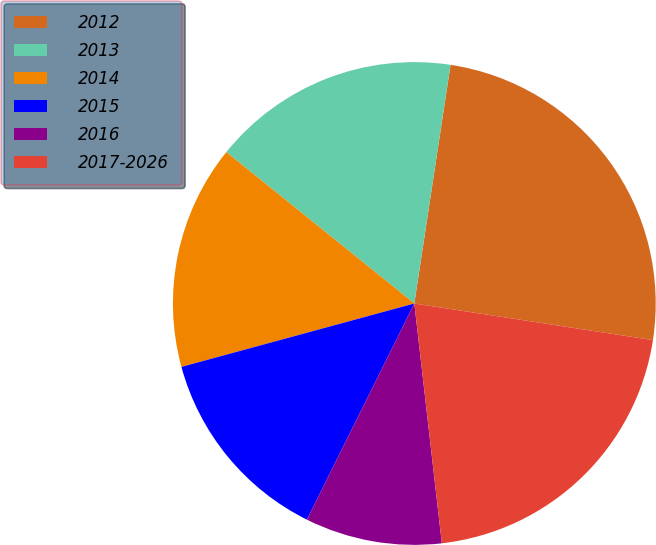Convert chart to OTSL. <chart><loc_0><loc_0><loc_500><loc_500><pie_chart><fcel>2012<fcel>2013<fcel>2014<fcel>2015<fcel>2016<fcel>2017-2026<nl><fcel>25.03%<fcel>16.61%<fcel>15.02%<fcel>13.43%<fcel>9.16%<fcel>20.76%<nl></chart> 